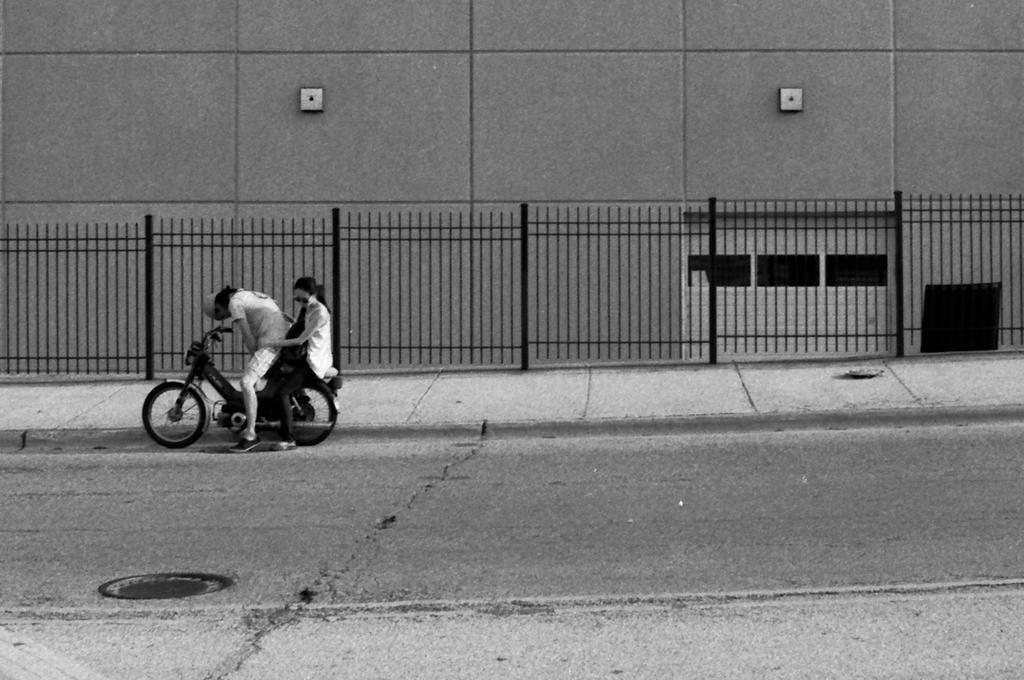Describe this image in one or two sentences. These two persons sitting on the vehicle. This person holding vehicle. This is road. This is fence. This is wall. 